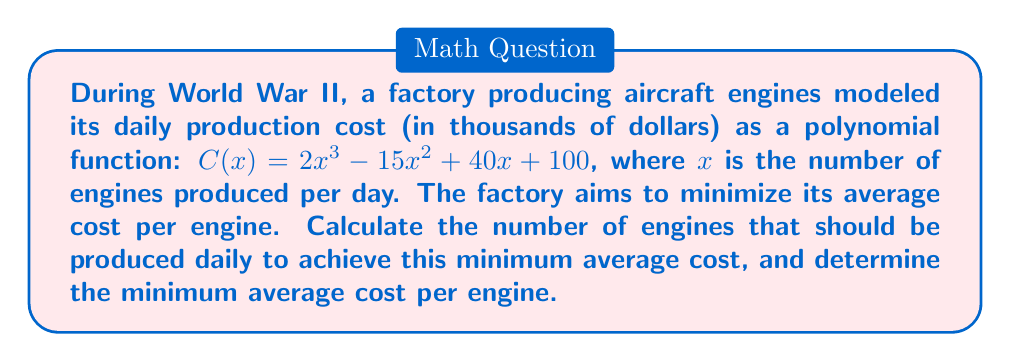Show me your answer to this math problem. To solve this problem, we'll follow these steps:

1) The average cost per engine is given by $A(x) = \frac{C(x)}{x}$

2) Substituting the given cost function:

   $A(x) = \frac{2x^3 - 15x^2 + 40x + 100}{x} = 2x^2 - 15x + 40 + \frac{100}{x}$

3) To find the minimum of this function, we need to differentiate it and set it to zero:

   $A'(x) = 4x - 15 - \frac{100}{x^2} = 0$

4) Multiply both sides by $x^2$:

   $4x^3 - 15x^2 - 100 = 0$

5) This is a cubic equation. It can be solved by factoring:

   $x^2(4x - 15) - 100 = 0$
   $(x^2 - 5)(4x + 5) = 0$

6) Solving this, we get $x = \sqrt{5}$ or $x = -\sqrt{5}$ or $x = -\frac{5}{4}$

7) Since $x$ represents the number of engines, it must be positive. Therefore, $x = \sqrt{5}$.

8) To confirm this is a minimum, we can check the second derivative is positive at this point.

9) To find the minimum average cost, we substitute $x = \sqrt{5}$ into the average cost function:

   $A(\sqrt{5}) = 2(\sqrt{5})^2 - 15\sqrt{5} + 40 + \frac{100}{\sqrt{5}}$
                $= 10 - 15\sqrt{5} + 40 + 20\sqrt{5}$
                $= 50 + 5\sqrt{5}$

This solution connects to the historical context by demonstrating how mathematical models were used to optimize wartime production, a crucial factor in the Allied victory in World War II.
Answer: The factory should produce $\sqrt{5} \approx 2.236$ engines per day to minimize the average cost. The minimum average cost per engine is $50 + 5\sqrt{5} \approx 61.18$ thousand dollars. 